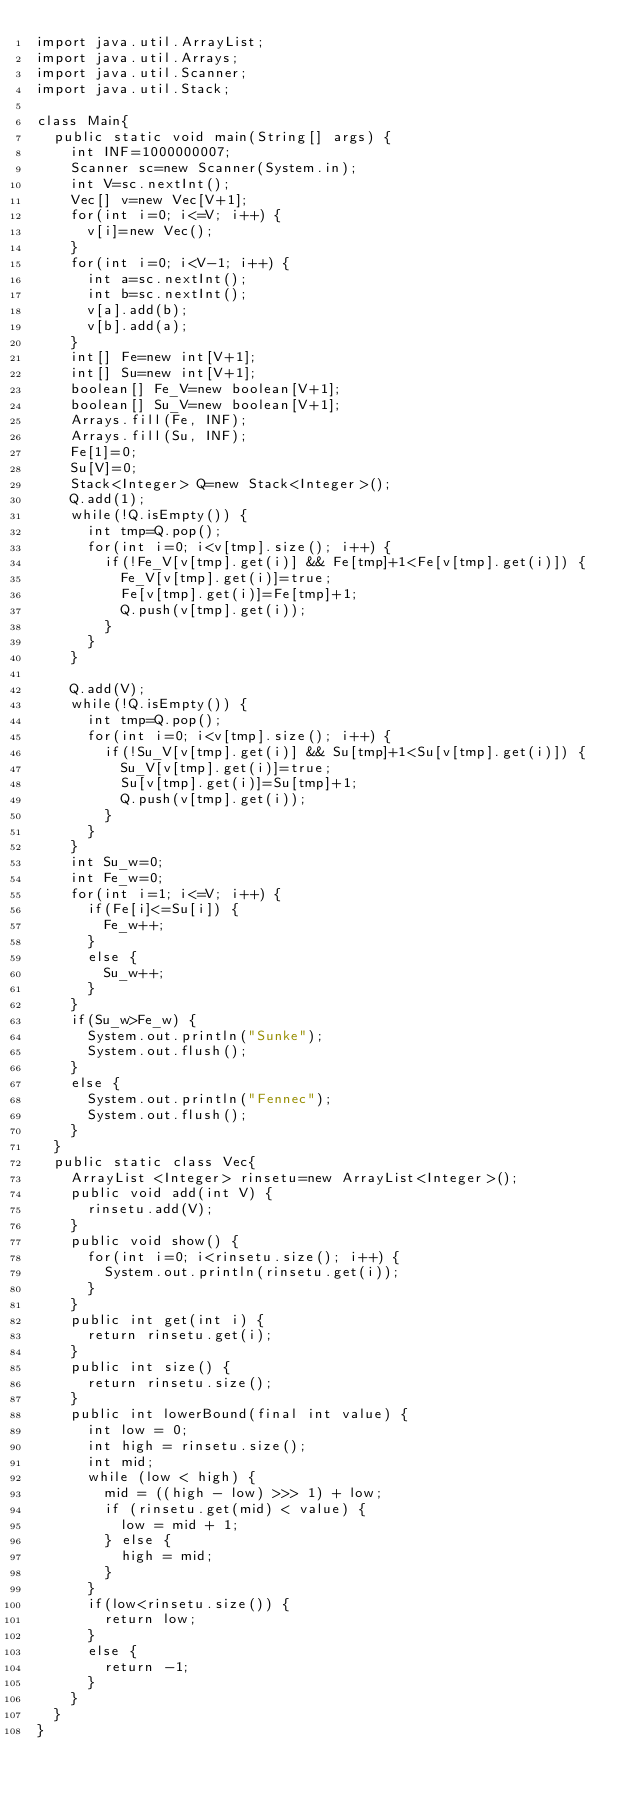<code> <loc_0><loc_0><loc_500><loc_500><_Java_>import java.util.ArrayList;
import java.util.Arrays;
import java.util.Scanner;
import java.util.Stack;

class Main{
	public static void main(String[] args) {
		int INF=1000000007;
		Scanner sc=new Scanner(System.in);
		int V=sc.nextInt();
		Vec[] v=new Vec[V+1];
		for(int i=0; i<=V; i++) {
			v[i]=new Vec();
		}
		for(int i=0; i<V-1; i++) {
			int a=sc.nextInt();
			int b=sc.nextInt();
			v[a].add(b);
			v[b].add(a);
		}
		int[] Fe=new int[V+1];
		int[] Su=new int[V+1];
		boolean[] Fe_V=new boolean[V+1];
		boolean[] Su_V=new boolean[V+1];
		Arrays.fill(Fe, INF);
		Arrays.fill(Su, INF);
		Fe[1]=0;
		Su[V]=0;
		Stack<Integer> Q=new Stack<Integer>();
		Q.add(1);
		while(!Q.isEmpty()) {
			int tmp=Q.pop();
			for(int i=0; i<v[tmp].size(); i++) {
				if(!Fe_V[v[tmp].get(i)] && Fe[tmp]+1<Fe[v[tmp].get(i)]) {
					Fe_V[v[tmp].get(i)]=true;
					Fe[v[tmp].get(i)]=Fe[tmp]+1;
					Q.push(v[tmp].get(i));
				}
			}
		}

		Q.add(V);
		while(!Q.isEmpty()) {
			int tmp=Q.pop();
			for(int i=0; i<v[tmp].size(); i++) {
				if(!Su_V[v[tmp].get(i)] && Su[tmp]+1<Su[v[tmp].get(i)]) {
					Su_V[v[tmp].get(i)]=true;
					Su[v[tmp].get(i)]=Su[tmp]+1;
					Q.push(v[tmp].get(i));
				}
			}
		}
		int Su_w=0;
		int Fe_w=0;
		for(int i=1; i<=V; i++) {
			if(Fe[i]<=Su[i]) {
				Fe_w++;
			}
			else {
				Su_w++;
			}
		}
		if(Su_w>Fe_w) {
			System.out.println("Sunke");
			System.out.flush();
		}
		else {
			System.out.println("Fennec");
			System.out.flush();
		}
	}
	public static class Vec{
		ArrayList <Integer> rinsetu=new ArrayList<Integer>();
		public void add(int V) {
			rinsetu.add(V);
		}
		public void show() {
			for(int i=0; i<rinsetu.size(); i++) {
				System.out.println(rinsetu.get(i));
			}
		}
		public int get(int i) {
			return rinsetu.get(i);
		}
		public int size() {
			return rinsetu.size();
		}
		public int lowerBound(final int value) {
			int low = 0;
			int high = rinsetu.size();
			int mid;
			while (low < high) {
				mid = ((high - low) >>> 1) + low;
				if (rinsetu.get(mid) < value) {
					low = mid + 1;
				} else {
					high = mid;
				}
			}
			if(low<rinsetu.size()) {
				return low;
			}
			else {
				return -1;
			}
		}
	}
}</code> 